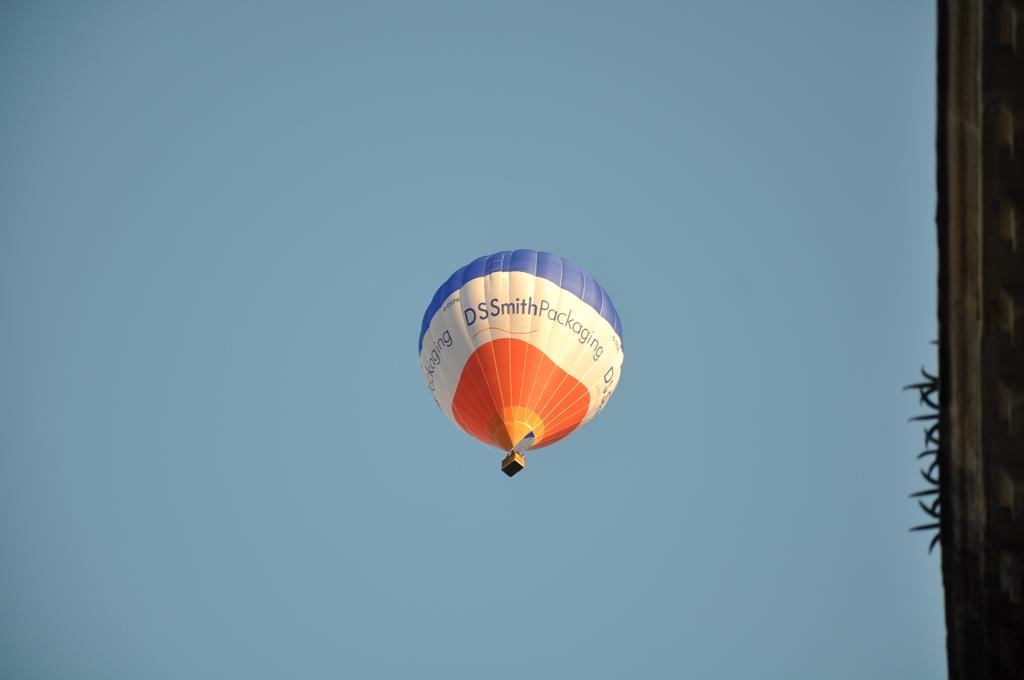<image>
Render a clear and concise summary of the photo. A hot air balloon in the air advertising DSsmith packaging. 